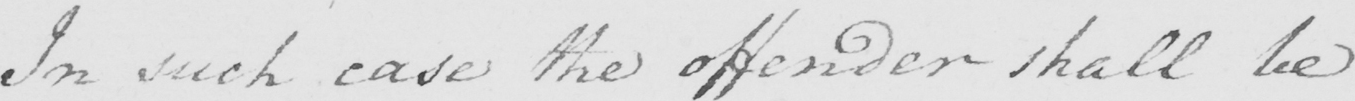Transcribe the text shown in this historical manuscript line. In such case the offender shall be 